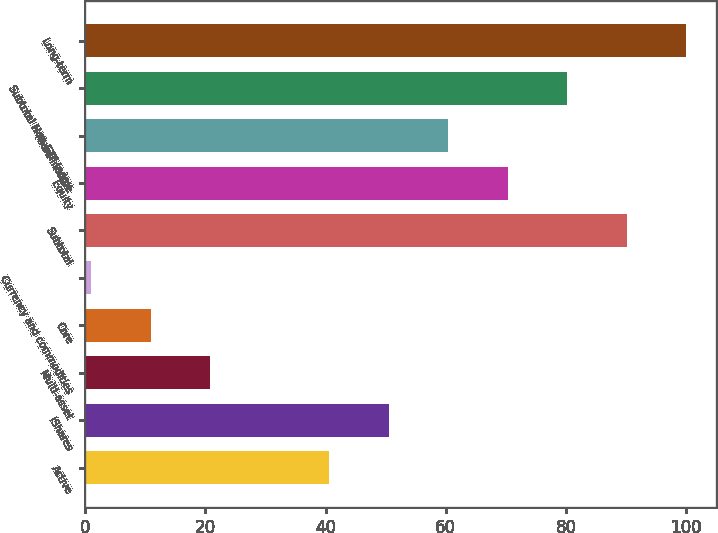Convert chart. <chart><loc_0><loc_0><loc_500><loc_500><bar_chart><fcel>Active<fcel>iShares<fcel>Multi-asset<fcel>Core<fcel>Currency and commodities<fcel>Subtotal<fcel>Equity<fcel>Fixed income<fcel>Subtotal Non-ETF Index<fcel>Long-term<nl><fcel>40.6<fcel>50.5<fcel>20.8<fcel>10.9<fcel>1<fcel>90.1<fcel>70.3<fcel>60.4<fcel>80.2<fcel>100<nl></chart> 